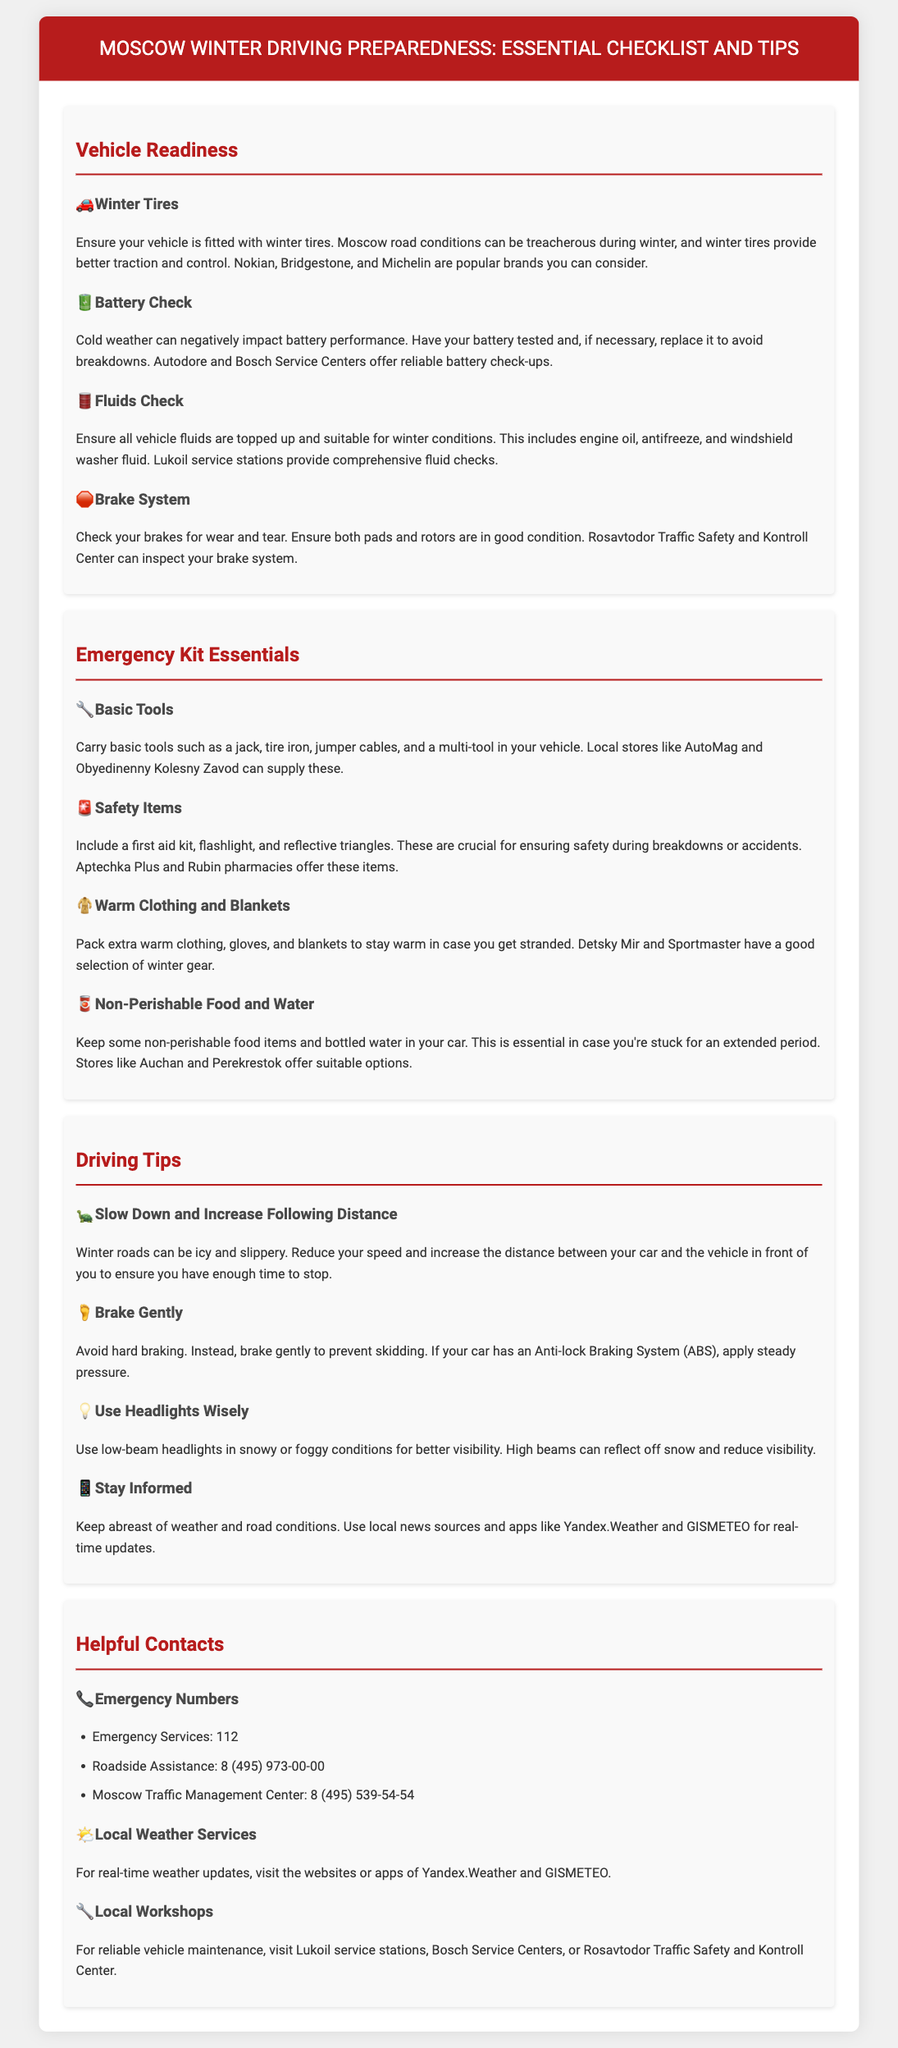what are the popular brands of winter tires? The document lists popular brands of winter tires to consider for Moscow road conditions, such as Nokian, Bridgestone, and Michelin.
Answer: Nokian, Bridgestone, Michelin what should you check to ensure battery performance? The document advises having your battery tested and replaced if necessary to avoid breakdowns in cold weather.
Answer: Battery tested what are essential items to include in an emergency kit? The emergency kit essentials include basic tools, safety items, warm clothing and blankets, and non-perishable food and water.
Answer: Basic tools, safety items, warm clothing, non-perishable food, water what is the emergency number for Moscow? The document states that the emergency services number in Moscow is 112.
Answer: 112 how should you adjust your driving speed in winter conditions? The text recommends reducing speed and increasing following distance when driving on icy winter roads.
Answer: Slow down and increase following distance where can you get your vehicle fluids checked? The document states that Lukoil service stations provide comprehensive fluid checks.
Answer: Lukoil service stations what does the document suggest about brake usage? It recommends braking gently to prevent skidding, especially when driving in winter conditions.
Answer: Brake gently what is the recommended way to use headlights in snowy conditions? The document advises using low-beam headlights for better visibility in snowy or foggy conditions.
Answer: Low-beam headlights 